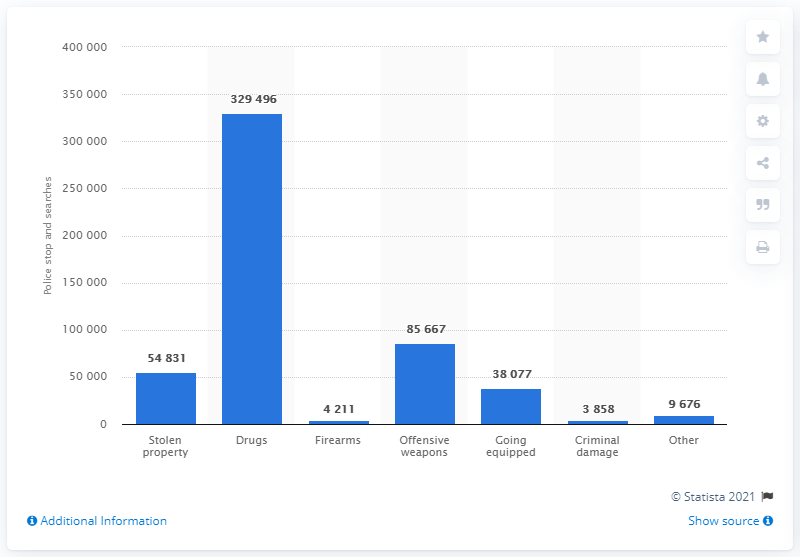Draw attention to some important aspects in this diagram. The police conducted a total of 329,496 searches under the Police and Criminal Evidence Act (PACE). 